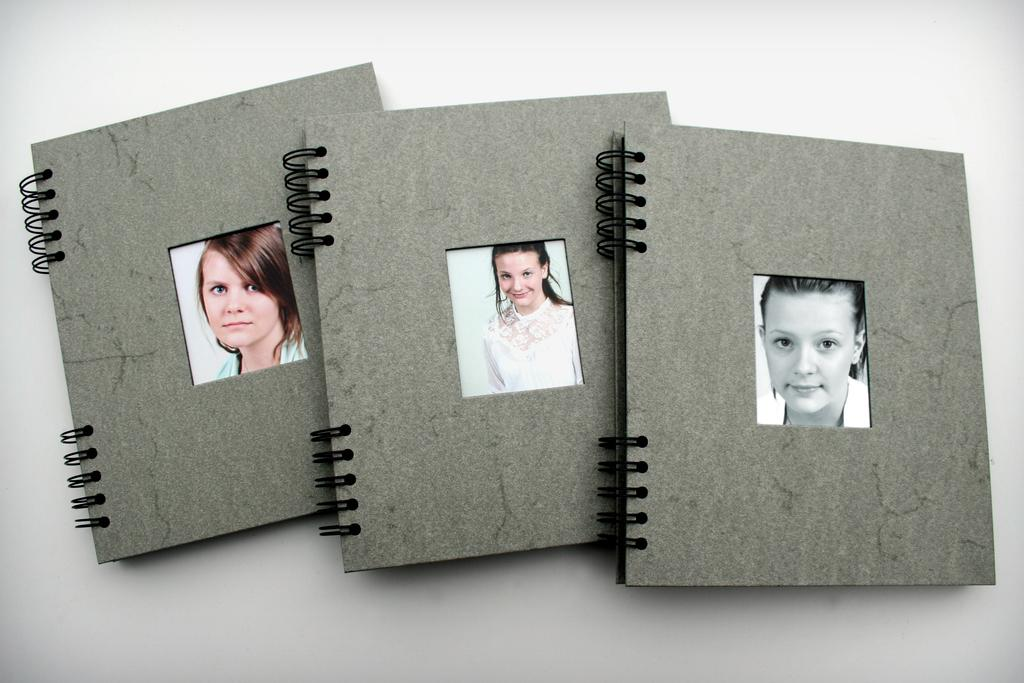How many books are visible in the image? There are 3 books in the image. What is the color of the books? The books are grey in color. What is depicted on the covers of the books? There is a picture of a woman on each book. What is the expression of the woman in the pictures? The woman in the pictures is smiling. What is the color of the surface on which the books are placed? The books are on a white surface. What type of secretary is shown working in the image? There is no secretary present in the image; it only features books with pictures of a smiling woman. 